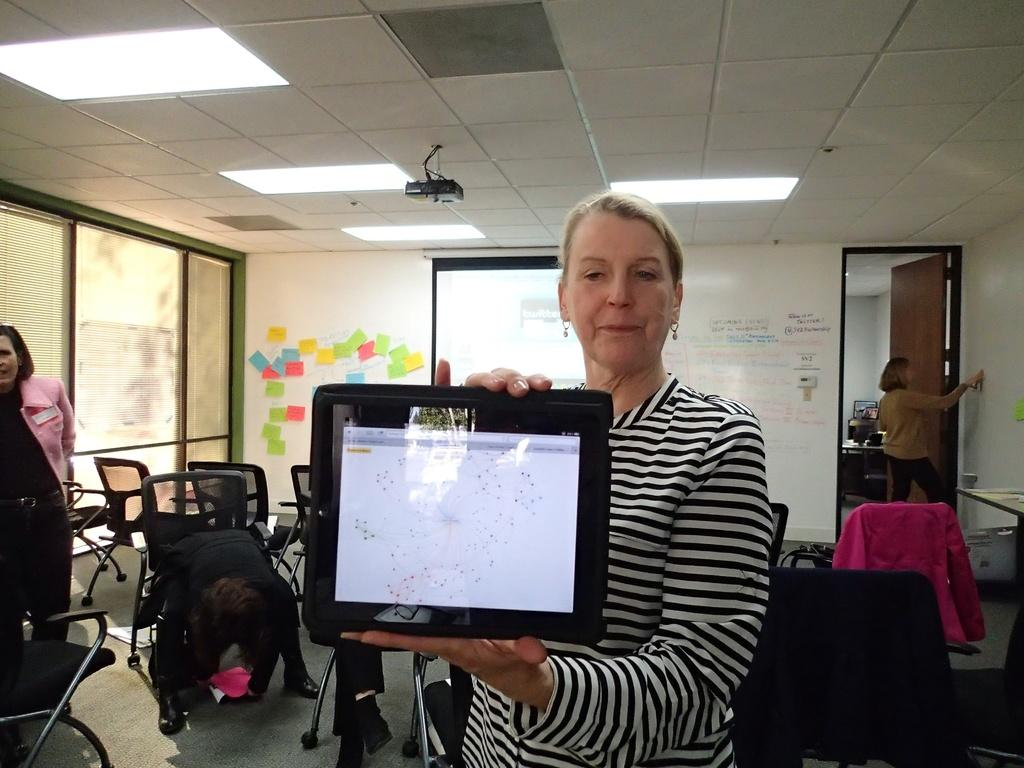What is the woman in the image holding? The woman is holding an electronic gadget in the image. What can be seen on the walls in the image? There are boards in the image. What device is used for displaying images or videos in the image? There is a projector in the image. What architectural feature allows access to different areas in the image? There is a door in the image. What type of furniture is present in the image? There are chairs in the image. What allows natural light to enter the room in the image? There is a window in the image. How many people are present in the image? There are people in the image. What type of yak can be seen grazing near the door in the image? There are no yaks present in the image; it features a woman holding an electronic gadget, boards, a projector, chairs, and a window. What organization is responsible for the meeting taking place in the image? The image does not provide any information about an organization or a meeting taking place. How does the room's acoustics affect the sound quality in the image? The image does not provide any information about the room's acoustics or sound quality. 